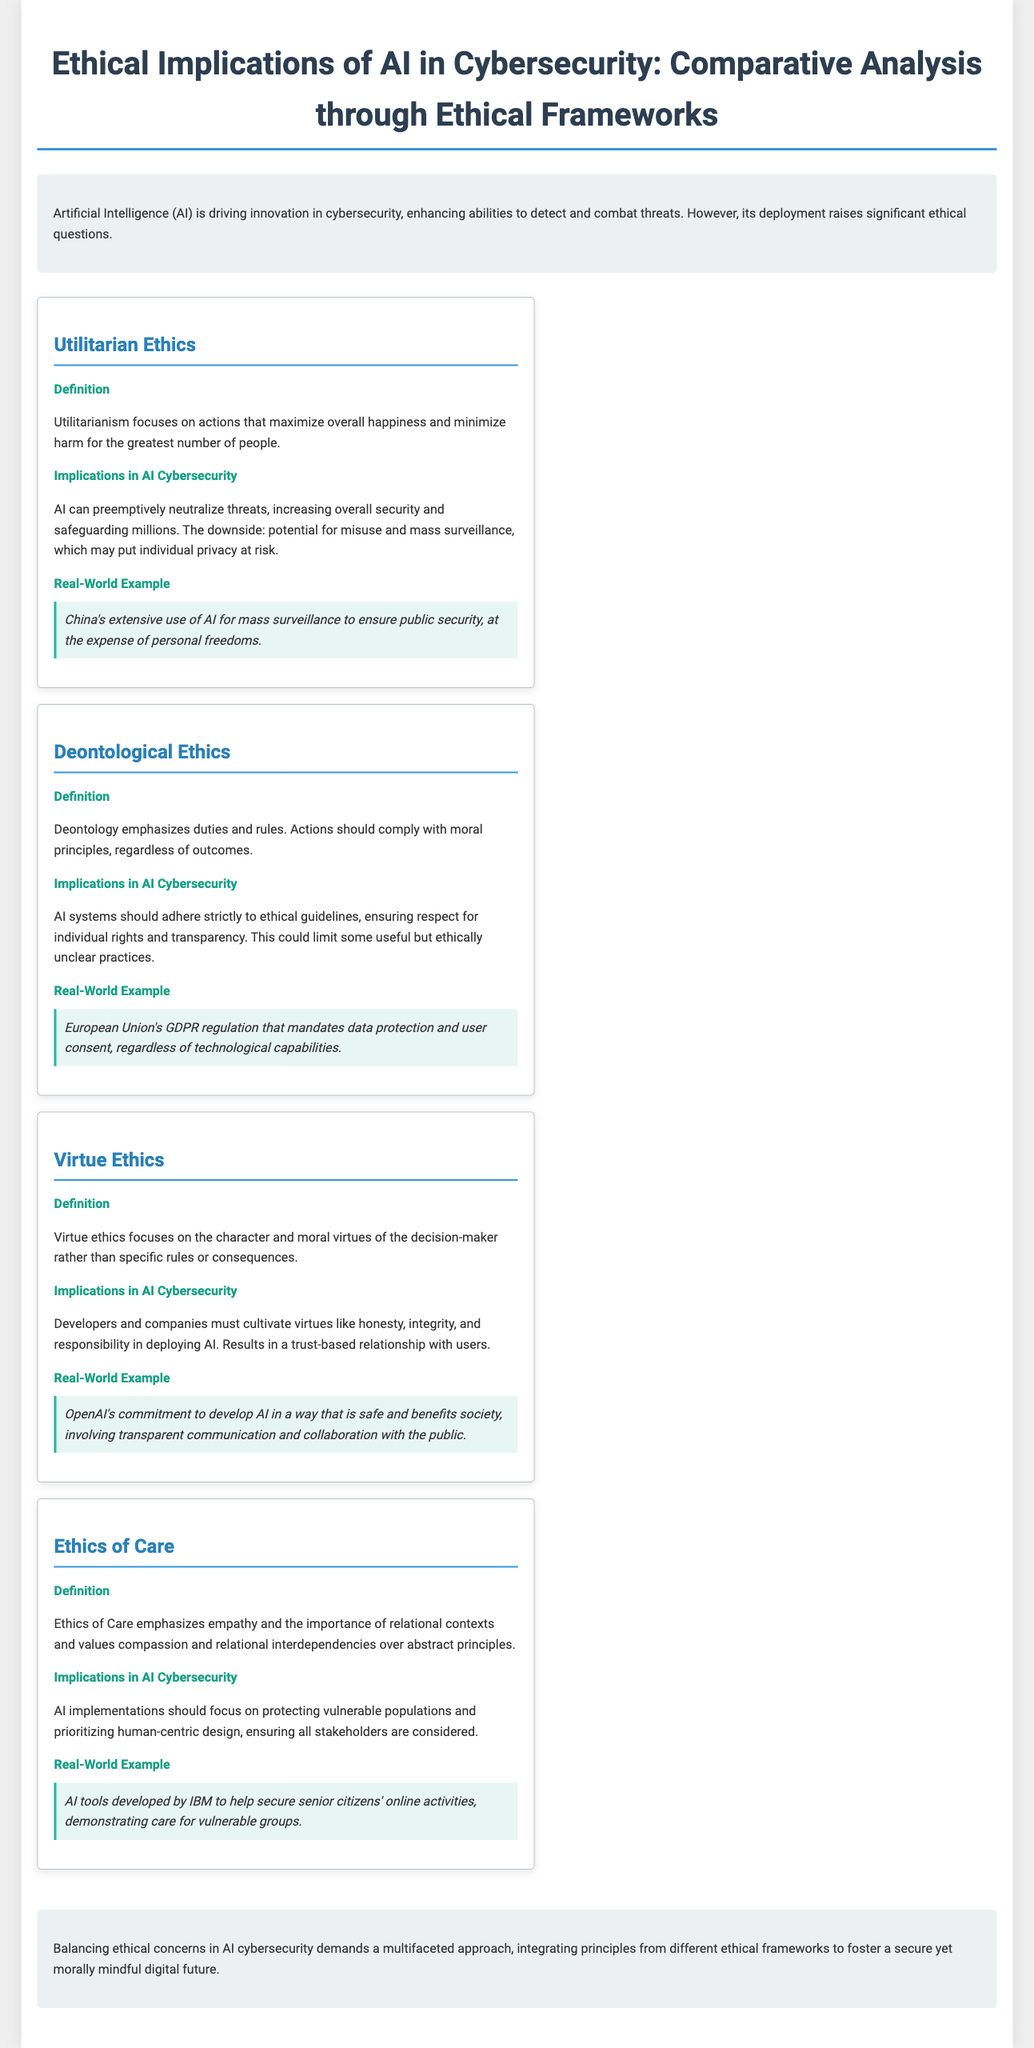What is the title of the document? The title of the document is provided at the top section, clearly indicated as the main heading.
Answer: Ethical Implications of AI in Cybersecurity: Comparative Analysis through Ethical Frameworks What ethical framework emphasizes duties and rules? This information is located in the section that defines each ethical framework.
Answer: Deontological Ethics What is the real-world example cited for Utilitarian ethics? The document provides a specific example under Utilitarian ethics showcasing its implications in practice.
Answer: China's extensive use of AI for mass surveillance Which ethical framework focuses on empathy and relational values? The document categorically defines each ethical framework, identifying their main focuses efficiently.
Answer: Ethics of Care What overarching conclusion does the document present? The conclusion summarizes the core message regarding the integration of ethical approaches in AI cybersecurity.
Answer: Balancing ethical concerns in AI cybersecurity demands a multifaceted approach What is the ethical principle emphasized in Virtue Ethics? The document highlights the focus of Virtue Ethics regarding the character of the decision-maker.
Answer: Moral virtues of the decision-maker How should AI systems adhere according to Deontological Ethics? This detail is included in the implications section discussing required adherence.
Answer: Strictly to ethical guidelines What technology is mentioned as being developed by IBM? The example is mentioned in the Ethics of Care section, illustrating a specific application in cybersecurity.
Answer: AI tools to help secure senior citizens' online activities 